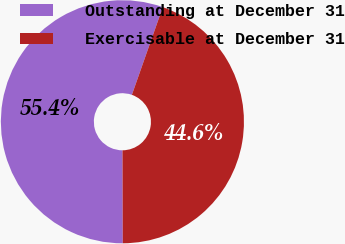<chart> <loc_0><loc_0><loc_500><loc_500><pie_chart><fcel>Outstanding at December 31<fcel>Exercisable at December 31<nl><fcel>55.44%<fcel>44.56%<nl></chart> 